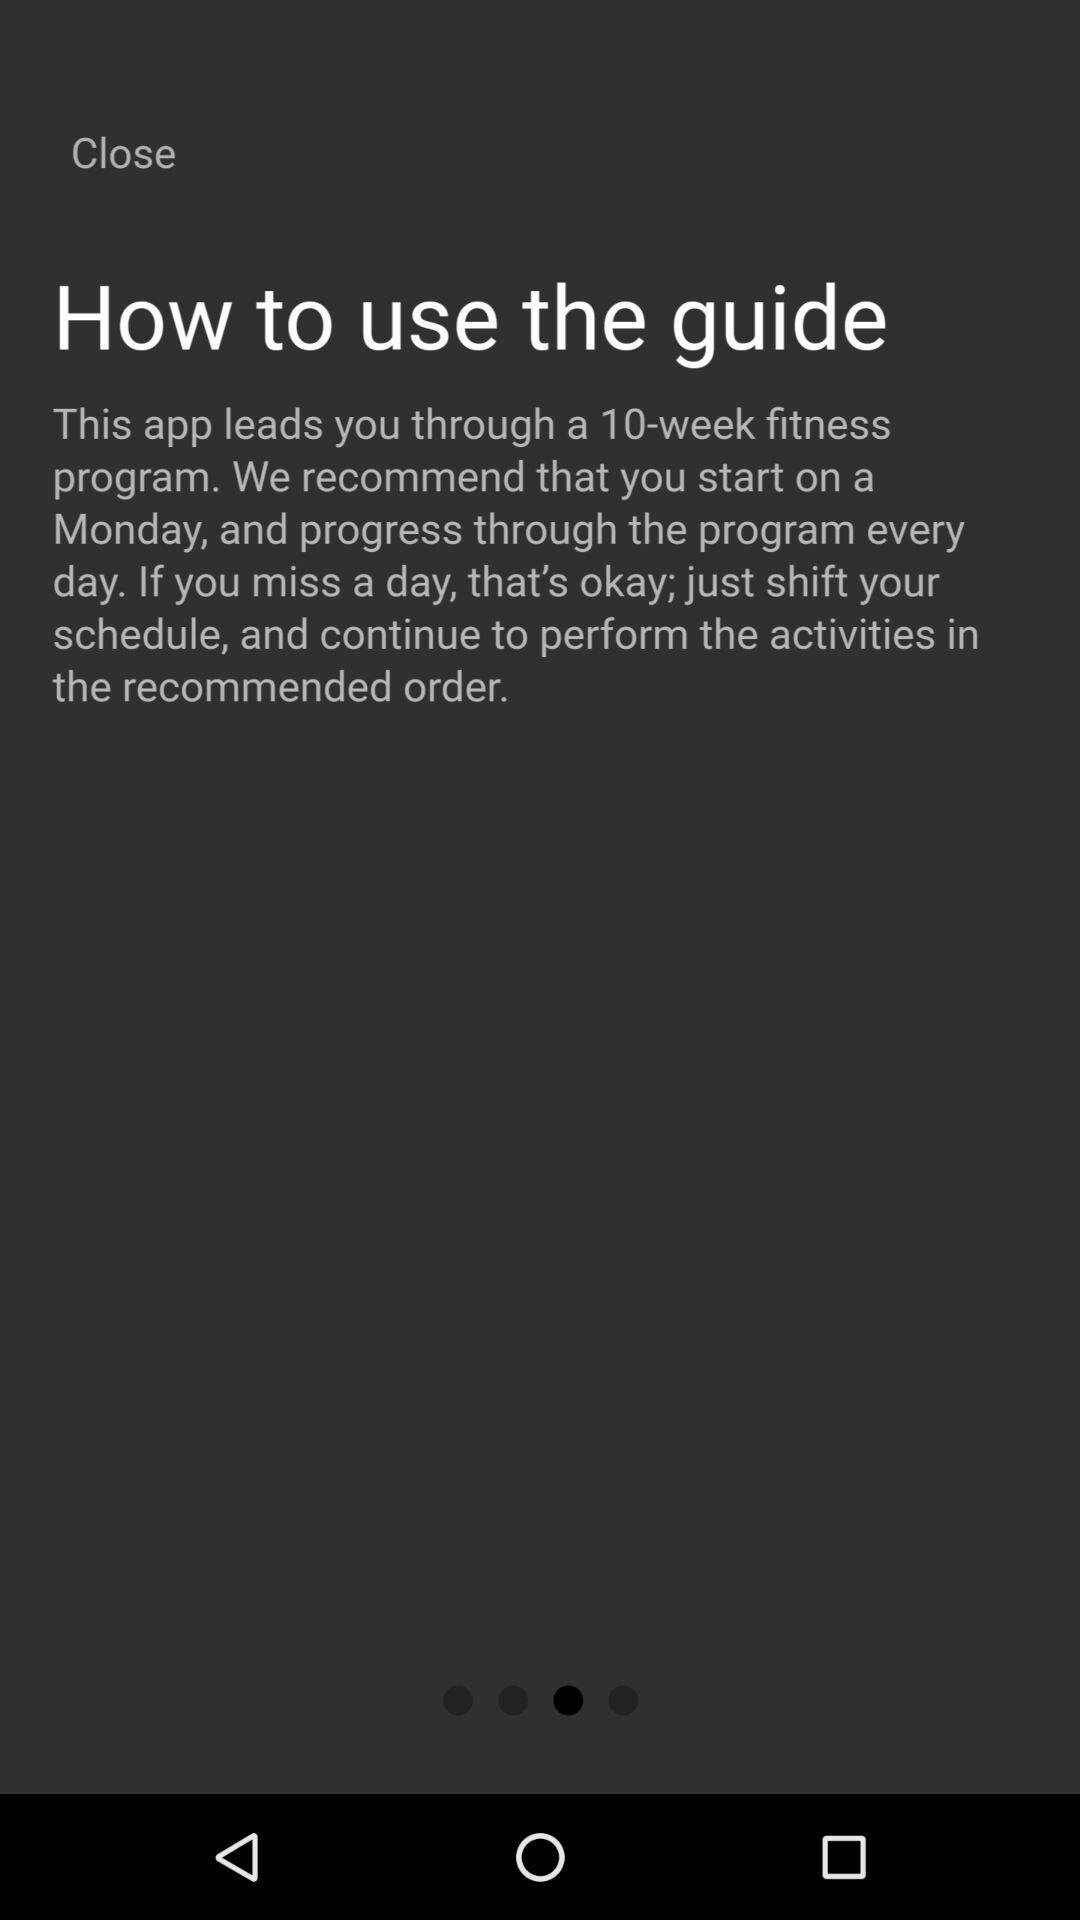How many weeks is the fitness challenge for? The fitness challenge is for 10 weeks. 